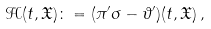<formula> <loc_0><loc_0><loc_500><loc_500>\mathcal { H } ( t , \mathfrak { X } ) \colon = ( \pi ^ { \prime } \sigma - \vartheta ^ { \prime } ) ( t , \mathfrak { X } ) \, ,</formula> 